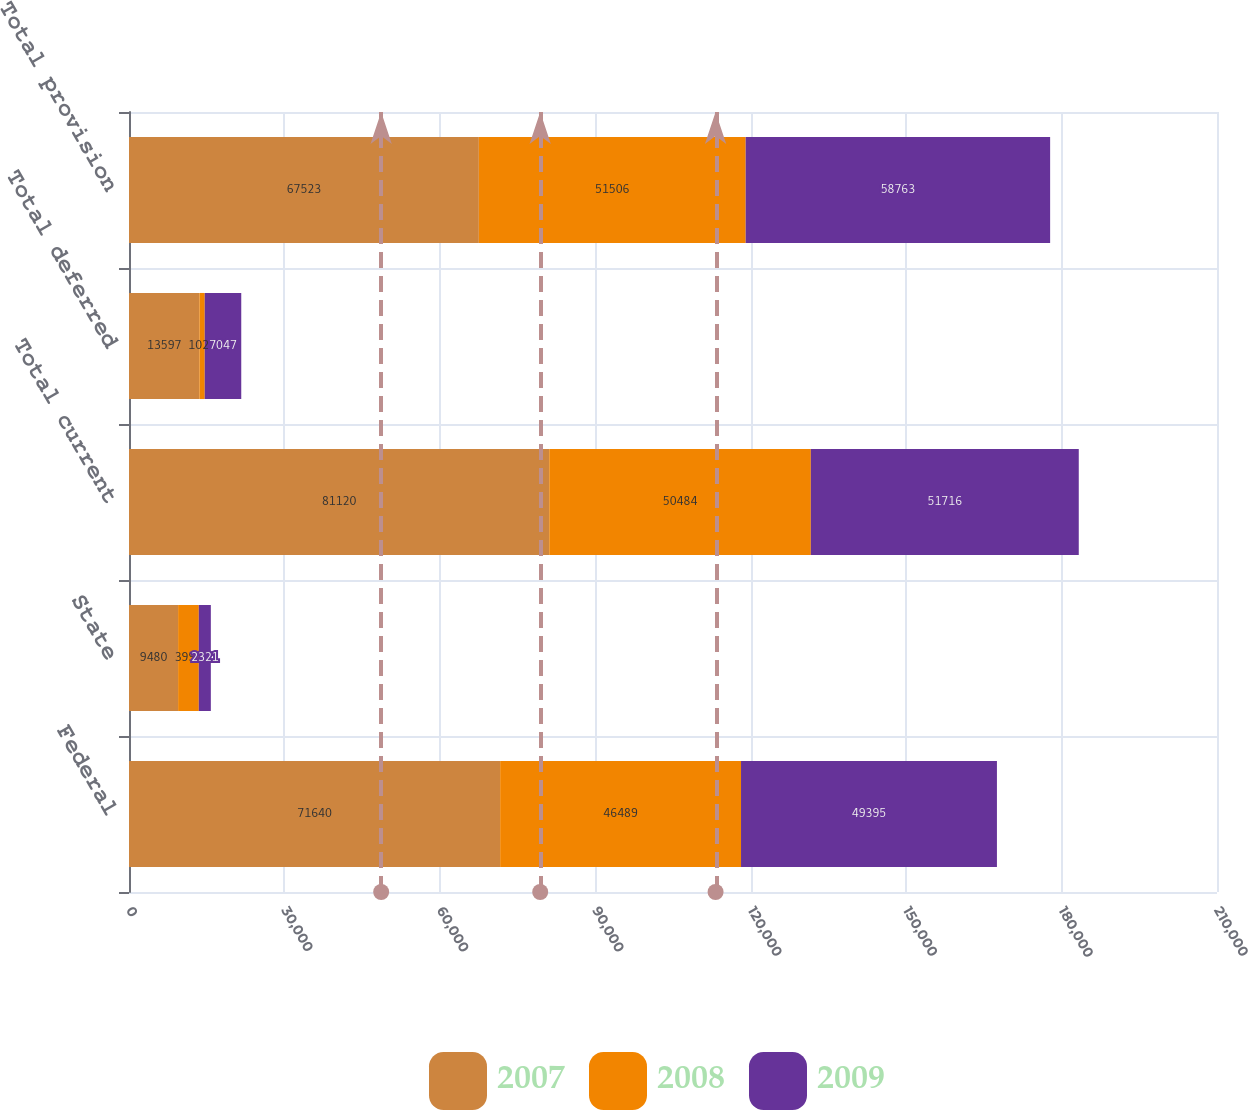Convert chart. <chart><loc_0><loc_0><loc_500><loc_500><stacked_bar_chart><ecel><fcel>Federal<fcel>State<fcel>Total current<fcel>Total deferred<fcel>Total provision<nl><fcel>2007<fcel>71640<fcel>9480<fcel>81120<fcel>13597<fcel>67523<nl><fcel>2008<fcel>46489<fcel>3995<fcel>50484<fcel>1022<fcel>51506<nl><fcel>2009<fcel>49395<fcel>2321<fcel>51716<fcel>7047<fcel>58763<nl></chart> 